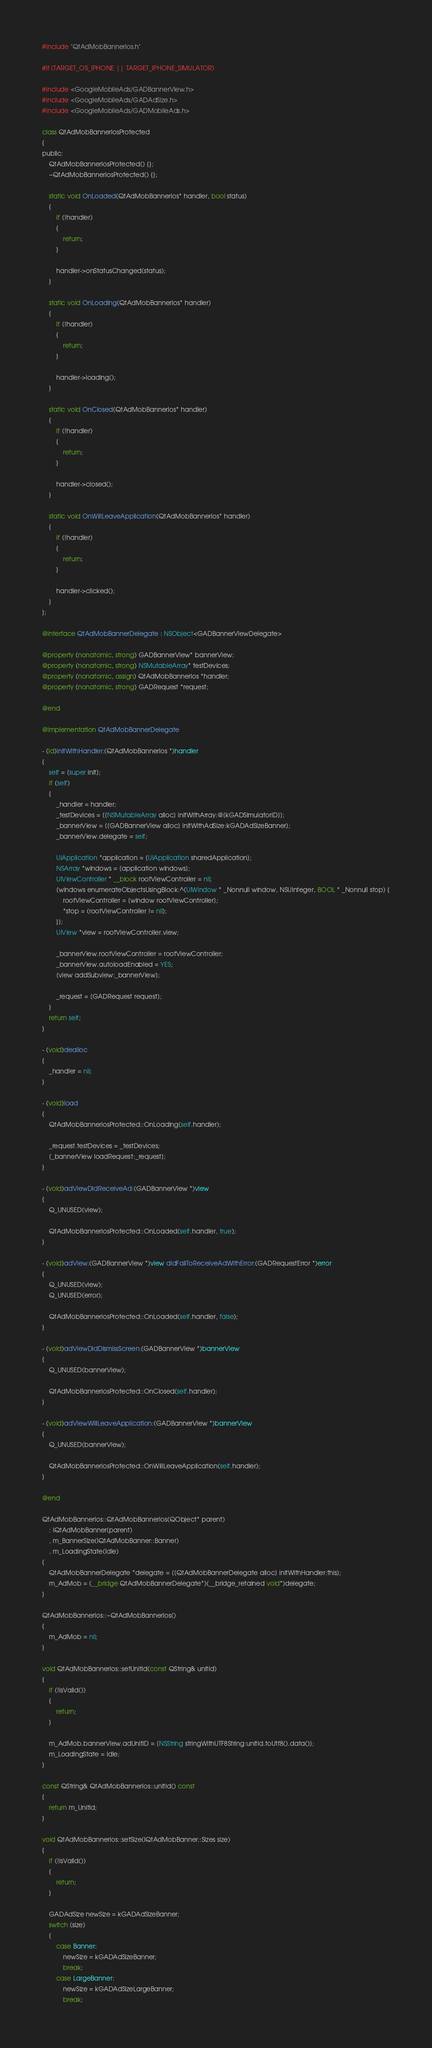Convert code to text. <code><loc_0><loc_0><loc_500><loc_500><_ObjectiveC_>#include "QtAdMobBannerIos.h"

#if (TARGET_OS_IPHONE || TARGET_IPHONE_SIMULATOR)

#include <GoogleMobileAds/GADBannerView.h>
#include <GoogleMobileAds/GADAdSize.h>
#include <GoogleMobileAds/GADMobileAds.h>

class QtAdMobBannerIosProtected
{
public:
    QtAdMobBannerIosProtected() {};
    ~QtAdMobBannerIosProtected() {};

    static void OnLoaded(QtAdMobBannerIos* handler, bool status)
    {
        if (!handler)
        {
            return;
        }

        handler->onStatusChanged(status);
    }

    static void OnLoading(QtAdMobBannerIos* handler)
    {
        if (!handler)
        {
            return;
        }

        handler->loading();
    }

    static void OnClosed(QtAdMobBannerIos* handler)
    {
        if (!handler)
        {
            return;
        }

        handler->closed();
    }

    static void OnWillLeaveApplication(QtAdMobBannerIos* handler)
    {
        if (!handler)
        {
            return;
        }

        handler->clicked();
    }
};

@interface QtAdMobBannerDelegate : NSObject<GADBannerViewDelegate>

@property (nonatomic, strong) GADBannerView* bannerView;
@property (nonatomic, strong) NSMutableArray* testDevices;
@property (nonatomic, assign) QtAdMobBannerIos *handler;
@property (nonatomic, strong) GADRequest *request;

@end

@implementation QtAdMobBannerDelegate

- (id)initWithHandler:(QtAdMobBannerIos *)handler
{
    self = [super init];
    if (self)
    {
        _handler = handler;
        _testDevices = [[NSMutableArray alloc] initWithArray:@[kGADSimulatorID]];
        _bannerView = [[GADBannerView alloc] initWithAdSize:kGADAdSizeBanner];
        _bannerView.delegate = self;
        
        UIApplication *application = [UIApplication sharedApplication];
        NSArray *windows = [application windows];
        UIViewController * __block rootViewController = nil;
        [windows enumerateObjectsUsingBlock:^(UIWindow * _Nonnull window, NSUInteger, BOOL * _Nonnull stop) {
            rootViewController = [window rootViewController];
            *stop = (rootViewController != nil);
        }];
        UIView *view = rootViewController.view;
        
        _bannerView.rootViewController = rootViewController;
        _bannerView.autoloadEnabled = YES;
        [view addSubview:_bannerView];

        _request = [GADRequest request];
    }
    return self;
}

- (void)dealloc
{
    _handler = nil;
}

- (void)load
{
    QtAdMobBannerIosProtected::OnLoading(self.handler);

    _request.testDevices = _testDevices;
    [_bannerView loadRequest:_request];
}

- (void)adViewDidReceiveAd:(GADBannerView *)view
{
    Q_UNUSED(view);
    
    QtAdMobBannerIosProtected::OnLoaded(self.handler, true);
}

- (void)adView:(GADBannerView *)view didFailToReceiveAdWithError:(GADRequestError *)error
{
    Q_UNUSED(view);
    Q_UNUSED(error);

    QtAdMobBannerIosProtected::OnLoaded(self.handler, false);
}

- (void)adViewDidDismissScreen:(GADBannerView *)bannerView
{
    Q_UNUSED(bannerView);

    QtAdMobBannerIosProtected::OnClosed(self.handler);
}

- (void)adViewWillLeaveApplication:(GADBannerView *)bannerView
{
    Q_UNUSED(bannerView);

    QtAdMobBannerIosProtected::OnWillLeaveApplication(self.handler);
}

@end

QtAdMobBannerIos::QtAdMobBannerIos(QObject* parent)
    : IQtAdMobBanner(parent)
    , m_BannerSize(IQtAdMobBanner::Banner)
    , m_LoadingState(Idle)
{
    QtAdMobBannerDelegate *delegate = [[QtAdMobBannerDelegate alloc] initWithHandler:this];
    m_AdMob = (__bridge QtAdMobBannerDelegate*)(__bridge_retained void*)delegate;
}

QtAdMobBannerIos::~QtAdMobBannerIos()
{
    m_AdMob = nil;
}

void QtAdMobBannerIos::setUnitId(const QString& unitId)
{
    if (!isValid())
    {
        return;
    }
    
    m_AdMob.bannerView.adUnitID = [NSString stringWithUTF8String:unitId.toUtf8().data()];
    m_LoadingState = Idle;
}

const QString& QtAdMobBannerIos::unitId() const
{
    return m_UnitId;
}

void QtAdMobBannerIos::setSize(IQtAdMobBanner::Sizes size)
{
    if (!isValid())
    {
        return;
    }
    
    GADAdSize newSize = kGADAdSizeBanner;
    switch (size)
    {
        case Banner:
            newSize = kGADAdSizeBanner;
            break;
        case LargeBanner:
            newSize = kGADAdSizeLargeBanner;
            break;</code> 